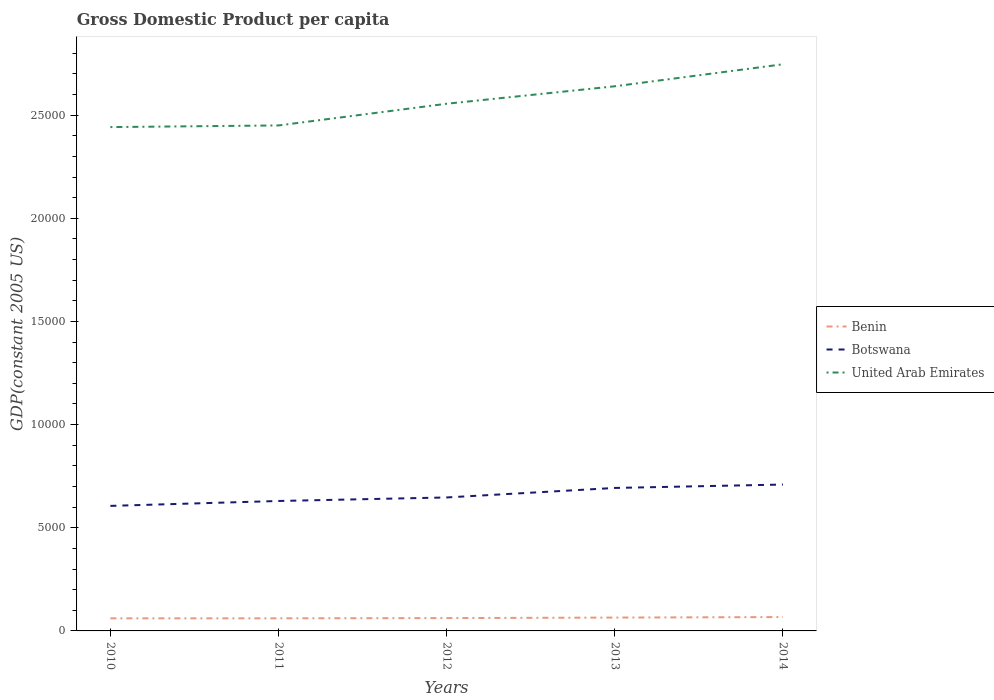Across all years, what is the maximum GDP per capita in United Arab Emirates?
Make the answer very short. 2.44e+04. What is the total GDP per capita in Benin in the graph?
Your response must be concise. -25.23. What is the difference between the highest and the second highest GDP per capita in Botswana?
Your answer should be compact. 1034.61. What is the difference between the highest and the lowest GDP per capita in Botswana?
Provide a short and direct response. 2. Is the GDP per capita in Benin strictly greater than the GDP per capita in United Arab Emirates over the years?
Your answer should be very brief. Yes. Are the values on the major ticks of Y-axis written in scientific E-notation?
Your answer should be very brief. No. Does the graph contain any zero values?
Your answer should be compact. No. Does the graph contain grids?
Keep it short and to the point. No. How many legend labels are there?
Make the answer very short. 3. How are the legend labels stacked?
Provide a succinct answer. Vertical. What is the title of the graph?
Keep it short and to the point. Gross Domestic Product per capita. Does "Brunei Darussalam" appear as one of the legend labels in the graph?
Your answer should be very brief. No. What is the label or title of the X-axis?
Your answer should be compact. Years. What is the label or title of the Y-axis?
Keep it short and to the point. GDP(constant 2005 US). What is the GDP(constant 2005 US) of Benin in 2010?
Make the answer very short. 609.92. What is the GDP(constant 2005 US) of Botswana in 2010?
Provide a short and direct response. 6061.01. What is the GDP(constant 2005 US) in United Arab Emirates in 2010?
Provide a succinct answer. 2.44e+04. What is the GDP(constant 2005 US) of Benin in 2011?
Provide a short and direct response. 610.67. What is the GDP(constant 2005 US) of Botswana in 2011?
Offer a very short reply. 6298.8. What is the GDP(constant 2005 US) in United Arab Emirates in 2011?
Provide a short and direct response. 2.45e+04. What is the GDP(constant 2005 US) in Benin in 2012?
Provide a short and direct response. 621.83. What is the GDP(constant 2005 US) in Botswana in 2012?
Ensure brevity in your answer.  6469.65. What is the GDP(constant 2005 US) of United Arab Emirates in 2012?
Make the answer very short. 2.56e+04. What is the GDP(constant 2005 US) of Benin in 2013?
Offer a very short reply. 647.07. What is the GDP(constant 2005 US) of Botswana in 2013?
Make the answer very short. 6930.79. What is the GDP(constant 2005 US) in United Arab Emirates in 2013?
Keep it short and to the point. 2.64e+04. What is the GDP(constant 2005 US) in Benin in 2014?
Keep it short and to the point. 671.43. What is the GDP(constant 2005 US) of Botswana in 2014?
Offer a terse response. 7095.63. What is the GDP(constant 2005 US) in United Arab Emirates in 2014?
Ensure brevity in your answer.  2.75e+04. Across all years, what is the maximum GDP(constant 2005 US) of Benin?
Give a very brief answer. 671.43. Across all years, what is the maximum GDP(constant 2005 US) of Botswana?
Make the answer very short. 7095.63. Across all years, what is the maximum GDP(constant 2005 US) in United Arab Emirates?
Make the answer very short. 2.75e+04. Across all years, what is the minimum GDP(constant 2005 US) in Benin?
Ensure brevity in your answer.  609.92. Across all years, what is the minimum GDP(constant 2005 US) in Botswana?
Your answer should be compact. 6061.01. Across all years, what is the minimum GDP(constant 2005 US) in United Arab Emirates?
Provide a succinct answer. 2.44e+04. What is the total GDP(constant 2005 US) of Benin in the graph?
Make the answer very short. 3160.92. What is the total GDP(constant 2005 US) of Botswana in the graph?
Offer a very short reply. 3.29e+04. What is the total GDP(constant 2005 US) in United Arab Emirates in the graph?
Provide a succinct answer. 1.28e+05. What is the difference between the GDP(constant 2005 US) of Benin in 2010 and that in 2011?
Keep it short and to the point. -0.76. What is the difference between the GDP(constant 2005 US) in Botswana in 2010 and that in 2011?
Keep it short and to the point. -237.79. What is the difference between the GDP(constant 2005 US) in United Arab Emirates in 2010 and that in 2011?
Ensure brevity in your answer.  -79.72. What is the difference between the GDP(constant 2005 US) in Benin in 2010 and that in 2012?
Your answer should be compact. -11.92. What is the difference between the GDP(constant 2005 US) in Botswana in 2010 and that in 2012?
Ensure brevity in your answer.  -408.63. What is the difference between the GDP(constant 2005 US) in United Arab Emirates in 2010 and that in 2012?
Your answer should be compact. -1131.6. What is the difference between the GDP(constant 2005 US) of Benin in 2010 and that in 2013?
Your answer should be very brief. -37.15. What is the difference between the GDP(constant 2005 US) in Botswana in 2010 and that in 2013?
Ensure brevity in your answer.  -869.78. What is the difference between the GDP(constant 2005 US) of United Arab Emirates in 2010 and that in 2013?
Ensure brevity in your answer.  -1978.08. What is the difference between the GDP(constant 2005 US) of Benin in 2010 and that in 2014?
Your response must be concise. -61.51. What is the difference between the GDP(constant 2005 US) in Botswana in 2010 and that in 2014?
Give a very brief answer. -1034.61. What is the difference between the GDP(constant 2005 US) of United Arab Emirates in 2010 and that in 2014?
Ensure brevity in your answer.  -3044.45. What is the difference between the GDP(constant 2005 US) in Benin in 2011 and that in 2012?
Provide a short and direct response. -11.16. What is the difference between the GDP(constant 2005 US) in Botswana in 2011 and that in 2012?
Ensure brevity in your answer.  -170.84. What is the difference between the GDP(constant 2005 US) of United Arab Emirates in 2011 and that in 2012?
Your response must be concise. -1051.88. What is the difference between the GDP(constant 2005 US) in Benin in 2011 and that in 2013?
Your answer should be very brief. -36.39. What is the difference between the GDP(constant 2005 US) in Botswana in 2011 and that in 2013?
Offer a very short reply. -631.99. What is the difference between the GDP(constant 2005 US) in United Arab Emirates in 2011 and that in 2013?
Keep it short and to the point. -1898.36. What is the difference between the GDP(constant 2005 US) of Benin in 2011 and that in 2014?
Offer a very short reply. -60.75. What is the difference between the GDP(constant 2005 US) in Botswana in 2011 and that in 2014?
Your answer should be very brief. -796.83. What is the difference between the GDP(constant 2005 US) in United Arab Emirates in 2011 and that in 2014?
Make the answer very short. -2964.72. What is the difference between the GDP(constant 2005 US) in Benin in 2012 and that in 2013?
Give a very brief answer. -25.23. What is the difference between the GDP(constant 2005 US) of Botswana in 2012 and that in 2013?
Your answer should be very brief. -461.15. What is the difference between the GDP(constant 2005 US) in United Arab Emirates in 2012 and that in 2013?
Keep it short and to the point. -846.47. What is the difference between the GDP(constant 2005 US) in Benin in 2012 and that in 2014?
Give a very brief answer. -49.59. What is the difference between the GDP(constant 2005 US) in Botswana in 2012 and that in 2014?
Your answer should be compact. -625.98. What is the difference between the GDP(constant 2005 US) in United Arab Emirates in 2012 and that in 2014?
Give a very brief answer. -1912.84. What is the difference between the GDP(constant 2005 US) in Benin in 2013 and that in 2014?
Provide a succinct answer. -24.36. What is the difference between the GDP(constant 2005 US) of Botswana in 2013 and that in 2014?
Provide a succinct answer. -164.84. What is the difference between the GDP(constant 2005 US) in United Arab Emirates in 2013 and that in 2014?
Make the answer very short. -1066.37. What is the difference between the GDP(constant 2005 US) in Benin in 2010 and the GDP(constant 2005 US) in Botswana in 2011?
Offer a very short reply. -5688.89. What is the difference between the GDP(constant 2005 US) in Benin in 2010 and the GDP(constant 2005 US) in United Arab Emirates in 2011?
Provide a succinct answer. -2.39e+04. What is the difference between the GDP(constant 2005 US) of Botswana in 2010 and the GDP(constant 2005 US) of United Arab Emirates in 2011?
Offer a very short reply. -1.84e+04. What is the difference between the GDP(constant 2005 US) of Benin in 2010 and the GDP(constant 2005 US) of Botswana in 2012?
Give a very brief answer. -5859.73. What is the difference between the GDP(constant 2005 US) in Benin in 2010 and the GDP(constant 2005 US) in United Arab Emirates in 2012?
Make the answer very short. -2.49e+04. What is the difference between the GDP(constant 2005 US) in Botswana in 2010 and the GDP(constant 2005 US) in United Arab Emirates in 2012?
Offer a terse response. -1.95e+04. What is the difference between the GDP(constant 2005 US) of Benin in 2010 and the GDP(constant 2005 US) of Botswana in 2013?
Offer a terse response. -6320.87. What is the difference between the GDP(constant 2005 US) of Benin in 2010 and the GDP(constant 2005 US) of United Arab Emirates in 2013?
Keep it short and to the point. -2.58e+04. What is the difference between the GDP(constant 2005 US) in Botswana in 2010 and the GDP(constant 2005 US) in United Arab Emirates in 2013?
Give a very brief answer. -2.03e+04. What is the difference between the GDP(constant 2005 US) of Benin in 2010 and the GDP(constant 2005 US) of Botswana in 2014?
Your answer should be very brief. -6485.71. What is the difference between the GDP(constant 2005 US) of Benin in 2010 and the GDP(constant 2005 US) of United Arab Emirates in 2014?
Your answer should be compact. -2.69e+04. What is the difference between the GDP(constant 2005 US) in Botswana in 2010 and the GDP(constant 2005 US) in United Arab Emirates in 2014?
Provide a succinct answer. -2.14e+04. What is the difference between the GDP(constant 2005 US) in Benin in 2011 and the GDP(constant 2005 US) in Botswana in 2012?
Provide a succinct answer. -5858.97. What is the difference between the GDP(constant 2005 US) in Benin in 2011 and the GDP(constant 2005 US) in United Arab Emirates in 2012?
Ensure brevity in your answer.  -2.49e+04. What is the difference between the GDP(constant 2005 US) in Botswana in 2011 and the GDP(constant 2005 US) in United Arab Emirates in 2012?
Provide a short and direct response. -1.93e+04. What is the difference between the GDP(constant 2005 US) in Benin in 2011 and the GDP(constant 2005 US) in Botswana in 2013?
Offer a very short reply. -6320.12. What is the difference between the GDP(constant 2005 US) in Benin in 2011 and the GDP(constant 2005 US) in United Arab Emirates in 2013?
Offer a very short reply. -2.58e+04. What is the difference between the GDP(constant 2005 US) in Botswana in 2011 and the GDP(constant 2005 US) in United Arab Emirates in 2013?
Offer a terse response. -2.01e+04. What is the difference between the GDP(constant 2005 US) in Benin in 2011 and the GDP(constant 2005 US) in Botswana in 2014?
Your answer should be very brief. -6484.95. What is the difference between the GDP(constant 2005 US) in Benin in 2011 and the GDP(constant 2005 US) in United Arab Emirates in 2014?
Give a very brief answer. -2.69e+04. What is the difference between the GDP(constant 2005 US) in Botswana in 2011 and the GDP(constant 2005 US) in United Arab Emirates in 2014?
Keep it short and to the point. -2.12e+04. What is the difference between the GDP(constant 2005 US) in Benin in 2012 and the GDP(constant 2005 US) in Botswana in 2013?
Make the answer very short. -6308.96. What is the difference between the GDP(constant 2005 US) of Benin in 2012 and the GDP(constant 2005 US) of United Arab Emirates in 2013?
Your answer should be very brief. -2.58e+04. What is the difference between the GDP(constant 2005 US) in Botswana in 2012 and the GDP(constant 2005 US) in United Arab Emirates in 2013?
Your answer should be very brief. -1.99e+04. What is the difference between the GDP(constant 2005 US) of Benin in 2012 and the GDP(constant 2005 US) of Botswana in 2014?
Ensure brevity in your answer.  -6473.79. What is the difference between the GDP(constant 2005 US) of Benin in 2012 and the GDP(constant 2005 US) of United Arab Emirates in 2014?
Keep it short and to the point. -2.68e+04. What is the difference between the GDP(constant 2005 US) of Botswana in 2012 and the GDP(constant 2005 US) of United Arab Emirates in 2014?
Your answer should be compact. -2.10e+04. What is the difference between the GDP(constant 2005 US) of Benin in 2013 and the GDP(constant 2005 US) of Botswana in 2014?
Your answer should be very brief. -6448.56. What is the difference between the GDP(constant 2005 US) of Benin in 2013 and the GDP(constant 2005 US) of United Arab Emirates in 2014?
Make the answer very short. -2.68e+04. What is the difference between the GDP(constant 2005 US) of Botswana in 2013 and the GDP(constant 2005 US) of United Arab Emirates in 2014?
Provide a short and direct response. -2.05e+04. What is the average GDP(constant 2005 US) of Benin per year?
Ensure brevity in your answer.  632.18. What is the average GDP(constant 2005 US) of Botswana per year?
Keep it short and to the point. 6571.18. What is the average GDP(constant 2005 US) of United Arab Emirates per year?
Offer a terse response. 2.57e+04. In the year 2010, what is the difference between the GDP(constant 2005 US) in Benin and GDP(constant 2005 US) in Botswana?
Your response must be concise. -5451.1. In the year 2010, what is the difference between the GDP(constant 2005 US) in Benin and GDP(constant 2005 US) in United Arab Emirates?
Your answer should be very brief. -2.38e+04. In the year 2010, what is the difference between the GDP(constant 2005 US) of Botswana and GDP(constant 2005 US) of United Arab Emirates?
Provide a succinct answer. -1.84e+04. In the year 2011, what is the difference between the GDP(constant 2005 US) in Benin and GDP(constant 2005 US) in Botswana?
Keep it short and to the point. -5688.13. In the year 2011, what is the difference between the GDP(constant 2005 US) of Benin and GDP(constant 2005 US) of United Arab Emirates?
Provide a succinct answer. -2.39e+04. In the year 2011, what is the difference between the GDP(constant 2005 US) of Botswana and GDP(constant 2005 US) of United Arab Emirates?
Keep it short and to the point. -1.82e+04. In the year 2012, what is the difference between the GDP(constant 2005 US) of Benin and GDP(constant 2005 US) of Botswana?
Your answer should be compact. -5847.81. In the year 2012, what is the difference between the GDP(constant 2005 US) of Benin and GDP(constant 2005 US) of United Arab Emirates?
Keep it short and to the point. -2.49e+04. In the year 2012, what is the difference between the GDP(constant 2005 US) of Botswana and GDP(constant 2005 US) of United Arab Emirates?
Your answer should be compact. -1.91e+04. In the year 2013, what is the difference between the GDP(constant 2005 US) of Benin and GDP(constant 2005 US) of Botswana?
Give a very brief answer. -6283.72. In the year 2013, what is the difference between the GDP(constant 2005 US) in Benin and GDP(constant 2005 US) in United Arab Emirates?
Keep it short and to the point. -2.58e+04. In the year 2013, what is the difference between the GDP(constant 2005 US) in Botswana and GDP(constant 2005 US) in United Arab Emirates?
Provide a succinct answer. -1.95e+04. In the year 2014, what is the difference between the GDP(constant 2005 US) in Benin and GDP(constant 2005 US) in Botswana?
Your answer should be compact. -6424.2. In the year 2014, what is the difference between the GDP(constant 2005 US) of Benin and GDP(constant 2005 US) of United Arab Emirates?
Provide a short and direct response. -2.68e+04. In the year 2014, what is the difference between the GDP(constant 2005 US) in Botswana and GDP(constant 2005 US) in United Arab Emirates?
Make the answer very short. -2.04e+04. What is the ratio of the GDP(constant 2005 US) of Botswana in 2010 to that in 2011?
Keep it short and to the point. 0.96. What is the ratio of the GDP(constant 2005 US) in United Arab Emirates in 2010 to that in 2011?
Ensure brevity in your answer.  1. What is the ratio of the GDP(constant 2005 US) of Benin in 2010 to that in 2012?
Make the answer very short. 0.98. What is the ratio of the GDP(constant 2005 US) of Botswana in 2010 to that in 2012?
Your answer should be very brief. 0.94. What is the ratio of the GDP(constant 2005 US) of United Arab Emirates in 2010 to that in 2012?
Give a very brief answer. 0.96. What is the ratio of the GDP(constant 2005 US) of Benin in 2010 to that in 2013?
Make the answer very short. 0.94. What is the ratio of the GDP(constant 2005 US) of Botswana in 2010 to that in 2013?
Provide a short and direct response. 0.87. What is the ratio of the GDP(constant 2005 US) of United Arab Emirates in 2010 to that in 2013?
Offer a terse response. 0.93. What is the ratio of the GDP(constant 2005 US) of Benin in 2010 to that in 2014?
Keep it short and to the point. 0.91. What is the ratio of the GDP(constant 2005 US) of Botswana in 2010 to that in 2014?
Provide a short and direct response. 0.85. What is the ratio of the GDP(constant 2005 US) of United Arab Emirates in 2010 to that in 2014?
Keep it short and to the point. 0.89. What is the ratio of the GDP(constant 2005 US) in Benin in 2011 to that in 2012?
Offer a very short reply. 0.98. What is the ratio of the GDP(constant 2005 US) of Botswana in 2011 to that in 2012?
Your answer should be very brief. 0.97. What is the ratio of the GDP(constant 2005 US) of United Arab Emirates in 2011 to that in 2012?
Give a very brief answer. 0.96. What is the ratio of the GDP(constant 2005 US) in Benin in 2011 to that in 2013?
Ensure brevity in your answer.  0.94. What is the ratio of the GDP(constant 2005 US) in Botswana in 2011 to that in 2013?
Give a very brief answer. 0.91. What is the ratio of the GDP(constant 2005 US) of United Arab Emirates in 2011 to that in 2013?
Offer a very short reply. 0.93. What is the ratio of the GDP(constant 2005 US) in Benin in 2011 to that in 2014?
Offer a very short reply. 0.91. What is the ratio of the GDP(constant 2005 US) in Botswana in 2011 to that in 2014?
Your response must be concise. 0.89. What is the ratio of the GDP(constant 2005 US) in United Arab Emirates in 2011 to that in 2014?
Offer a terse response. 0.89. What is the ratio of the GDP(constant 2005 US) of Benin in 2012 to that in 2013?
Provide a short and direct response. 0.96. What is the ratio of the GDP(constant 2005 US) in Botswana in 2012 to that in 2013?
Give a very brief answer. 0.93. What is the ratio of the GDP(constant 2005 US) of United Arab Emirates in 2012 to that in 2013?
Your answer should be very brief. 0.97. What is the ratio of the GDP(constant 2005 US) in Benin in 2012 to that in 2014?
Give a very brief answer. 0.93. What is the ratio of the GDP(constant 2005 US) of Botswana in 2012 to that in 2014?
Offer a very short reply. 0.91. What is the ratio of the GDP(constant 2005 US) in United Arab Emirates in 2012 to that in 2014?
Your response must be concise. 0.93. What is the ratio of the GDP(constant 2005 US) in Benin in 2013 to that in 2014?
Your answer should be very brief. 0.96. What is the ratio of the GDP(constant 2005 US) in Botswana in 2013 to that in 2014?
Provide a short and direct response. 0.98. What is the ratio of the GDP(constant 2005 US) in United Arab Emirates in 2013 to that in 2014?
Your response must be concise. 0.96. What is the difference between the highest and the second highest GDP(constant 2005 US) of Benin?
Your answer should be compact. 24.36. What is the difference between the highest and the second highest GDP(constant 2005 US) of Botswana?
Give a very brief answer. 164.84. What is the difference between the highest and the second highest GDP(constant 2005 US) in United Arab Emirates?
Your answer should be very brief. 1066.37. What is the difference between the highest and the lowest GDP(constant 2005 US) of Benin?
Offer a terse response. 61.51. What is the difference between the highest and the lowest GDP(constant 2005 US) of Botswana?
Give a very brief answer. 1034.61. What is the difference between the highest and the lowest GDP(constant 2005 US) of United Arab Emirates?
Your answer should be compact. 3044.45. 